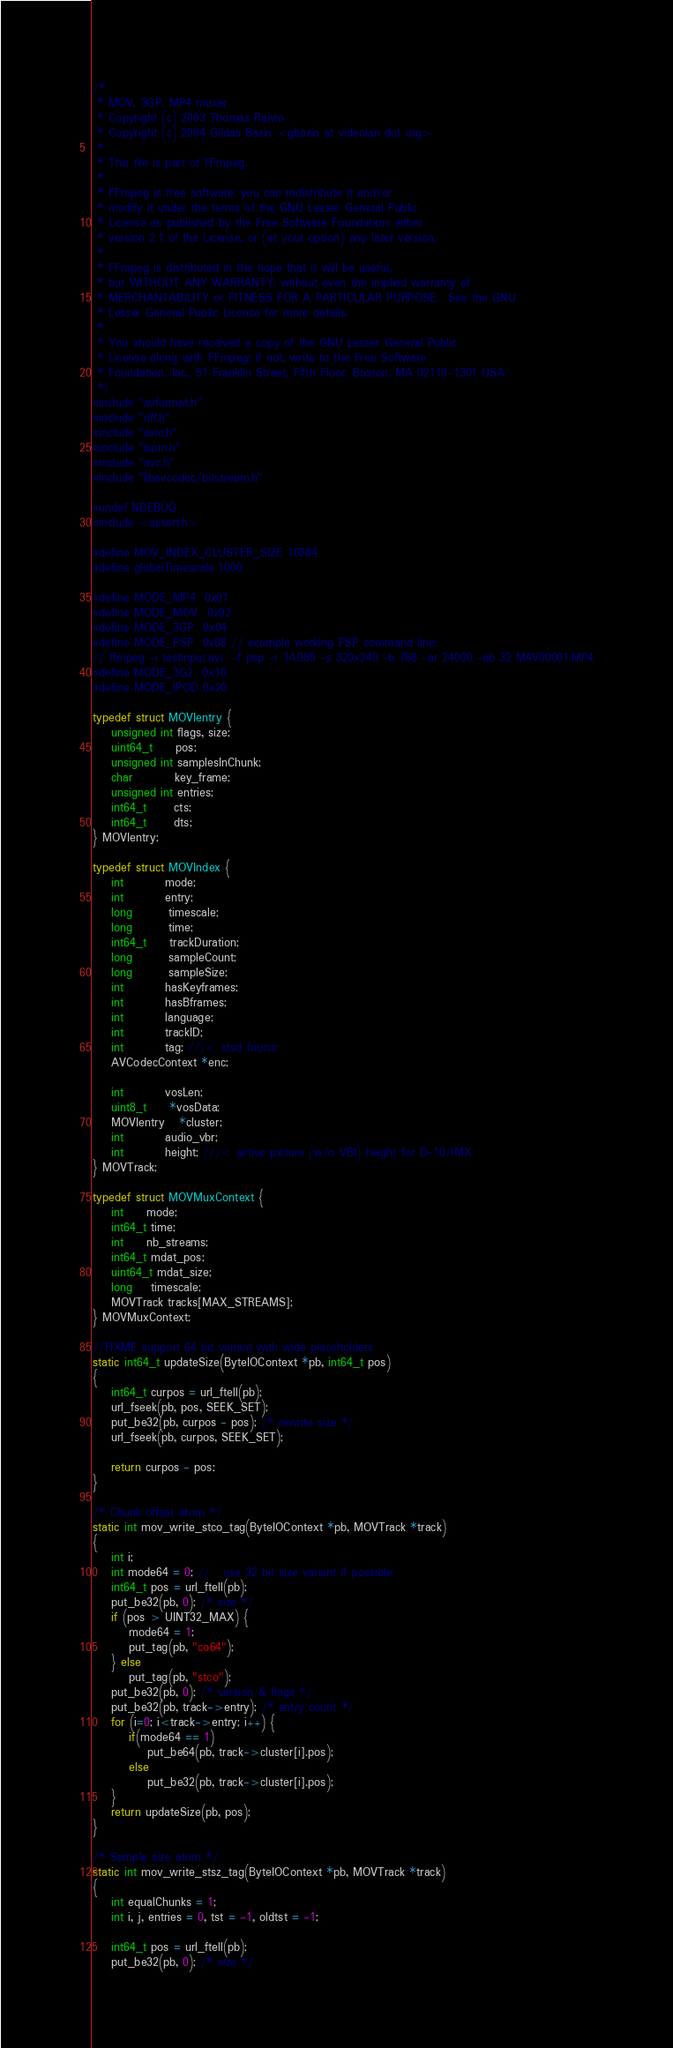<code> <loc_0><loc_0><loc_500><loc_500><_C_>/*
 * MOV, 3GP, MP4 muxer
 * Copyright (c) 2003 Thomas Raivio
 * Copyright (c) 2004 Gildas Bazin <gbazin at videolan dot org>
 *
 * This file is part of FFmpeg.
 *
 * FFmpeg is free software; you can redistribute it and/or
 * modify it under the terms of the GNU Lesser General Public
 * License as published by the Free Software Foundation; either
 * version 2.1 of the License, or (at your option) any later version.
 *
 * FFmpeg is distributed in the hope that it will be useful,
 * but WITHOUT ANY WARRANTY; without even the implied warranty of
 * MERCHANTABILITY or FITNESS FOR A PARTICULAR PURPOSE.  See the GNU
 * Lesser General Public License for more details.
 *
 * You should have received a copy of the GNU Lesser General Public
 * License along with FFmpeg; if not, write to the Free Software
 * Foundation, Inc., 51 Franklin Street, Fifth Floor, Boston, MA 02110-1301 USA
 */
#include "avformat.h"
#include "riff.h"
#include "avio.h"
#include "isom.h"
#include "avc.h"
#include "libavcodec/bitstream.h"

#undef NDEBUG
#include <assert.h>

#define MOV_INDEX_CLUSTER_SIZE 16384
#define globalTimescale 1000

#define MODE_MP4  0x01
#define MODE_MOV  0x02
#define MODE_3GP  0x04
#define MODE_PSP  0x08 // example working PSP command line:
// ffmpeg -i testinput.avi  -f psp -r 14.985 -s 320x240 -b 768 -ar 24000 -ab 32 M4V00001.MP4
#define MODE_3G2  0x10
#define MODE_IPOD 0x20

typedef struct MOVIentry {
    unsigned int flags, size;
    uint64_t     pos;
    unsigned int samplesInChunk;
    char         key_frame;
    unsigned int entries;
    int64_t      cts;
    int64_t      dts;
} MOVIentry;

typedef struct MOVIndex {
    int         mode;
    int         entry;
    long        timescale;
    long        time;
    int64_t     trackDuration;
    long        sampleCount;
    long        sampleSize;
    int         hasKeyframes;
    int         hasBframes;
    int         language;
    int         trackID;
    int         tag; ///< stsd fourcc
    AVCodecContext *enc;

    int         vosLen;
    uint8_t     *vosData;
    MOVIentry   *cluster;
    int         audio_vbr;
    int         height; ///< active picture (w/o VBI) height for D-10/IMX
} MOVTrack;

typedef struct MOVMuxContext {
    int     mode;
    int64_t time;
    int     nb_streams;
    int64_t mdat_pos;
    uint64_t mdat_size;
    long    timescale;
    MOVTrack tracks[MAX_STREAMS];
} MOVMuxContext;

//FIXME support 64 bit variant with wide placeholders
static int64_t updateSize(ByteIOContext *pb, int64_t pos)
{
    int64_t curpos = url_ftell(pb);
    url_fseek(pb, pos, SEEK_SET);
    put_be32(pb, curpos - pos); /* rewrite size */
    url_fseek(pb, curpos, SEEK_SET);

    return curpos - pos;
}

/* Chunk offset atom */
static int mov_write_stco_tag(ByteIOContext *pb, MOVTrack *track)
{
    int i;
    int mode64 = 0; //   use 32 bit size variant if possible
    int64_t pos = url_ftell(pb);
    put_be32(pb, 0); /* size */
    if (pos > UINT32_MAX) {
        mode64 = 1;
        put_tag(pb, "co64");
    } else
        put_tag(pb, "stco");
    put_be32(pb, 0); /* version & flags */
    put_be32(pb, track->entry); /* entry count */
    for (i=0; i<track->entry; i++) {
        if(mode64 == 1)
            put_be64(pb, track->cluster[i].pos);
        else
            put_be32(pb, track->cluster[i].pos);
    }
    return updateSize(pb, pos);
}

/* Sample size atom */
static int mov_write_stsz_tag(ByteIOContext *pb, MOVTrack *track)
{
    int equalChunks = 1;
    int i, j, entries = 0, tst = -1, oldtst = -1;

    int64_t pos = url_ftell(pb);
    put_be32(pb, 0); /* size */</code> 